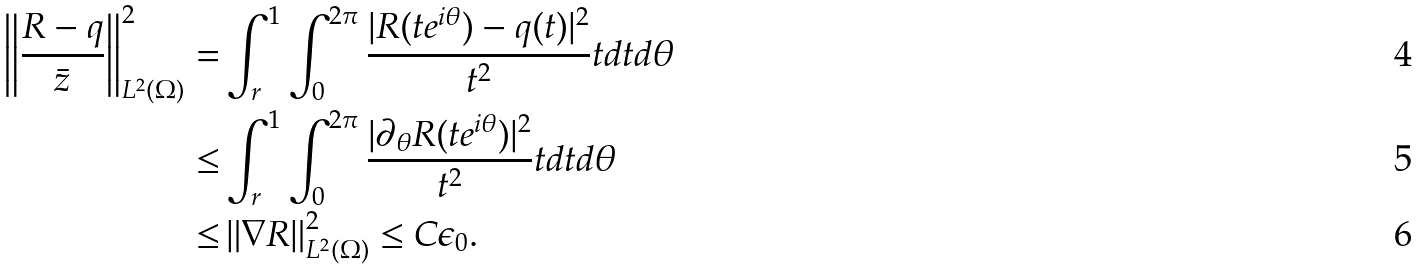Convert formula to latex. <formula><loc_0><loc_0><loc_500><loc_500>\left \| \frac { R - q } { \bar { z } } \right \| _ { L ^ { 2 } ( \Omega ) } ^ { 2 } = & \int _ { r } ^ { 1 } \int _ { 0 } ^ { 2 \pi } \frac { | R ( t e ^ { i \theta } ) - q ( t ) | ^ { 2 } } { t ^ { 2 } } t d t d \theta \\ \leq & \int _ { r } ^ { 1 } \int _ { 0 } ^ { 2 \pi } \frac { | \partial _ { \theta } R ( t e ^ { i \theta } ) | ^ { 2 } } { t ^ { 2 } } t d t d \theta \\ \leq & \left \| \nabla { R } \right \| _ { L ^ { 2 } ( \Omega ) } ^ { 2 } \leq C \epsilon _ { 0 } .</formula> 